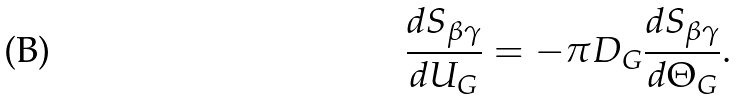Convert formula to latex. <formula><loc_0><loc_0><loc_500><loc_500>\frac { d S _ { \beta \gamma } } { d U _ { G } } = - \pi D _ { G } \frac { d S _ { \beta \gamma } } { d { \Theta _ { G } } } .</formula> 